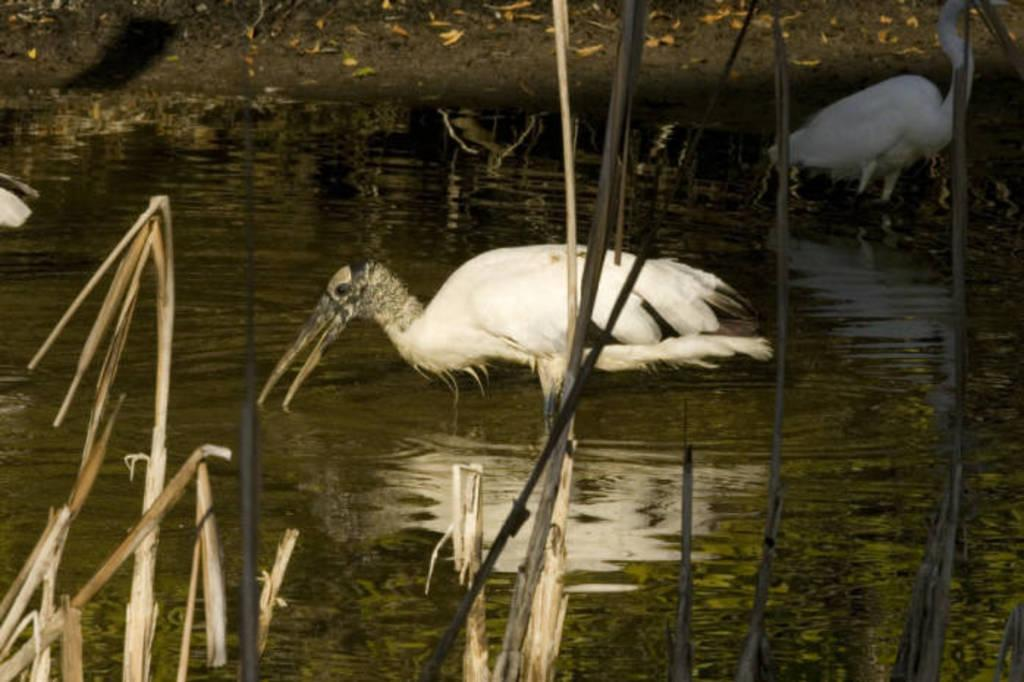What type of animals are in the water in the image? There are cranes in the water in the image. Where are the cranes located in relation to a specific place? The cranes are present over a place. What type of vegetation can be seen in the image? Small plants are visible in the image. What type of vegetable is being played by the band in the image? There is no vegetable or band present in the image. 